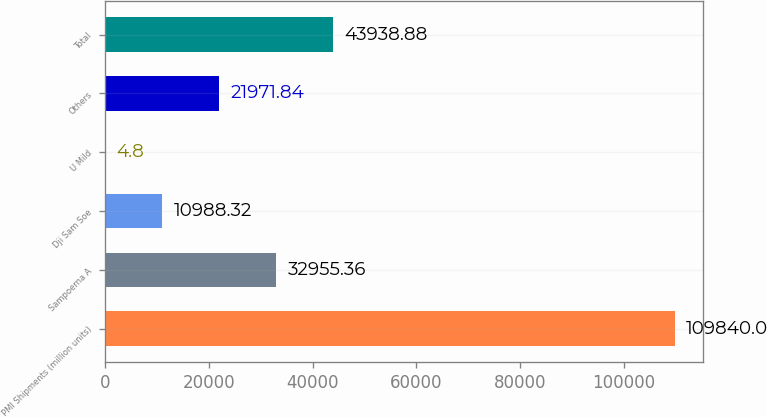<chart> <loc_0><loc_0><loc_500><loc_500><bar_chart><fcel>PMI Shipments (million units)<fcel>Sampoerna A<fcel>Dji Sam Soe<fcel>U Mild<fcel>Others<fcel>Total<nl><fcel>109840<fcel>32955.4<fcel>10988.3<fcel>4.8<fcel>21971.8<fcel>43938.9<nl></chart> 